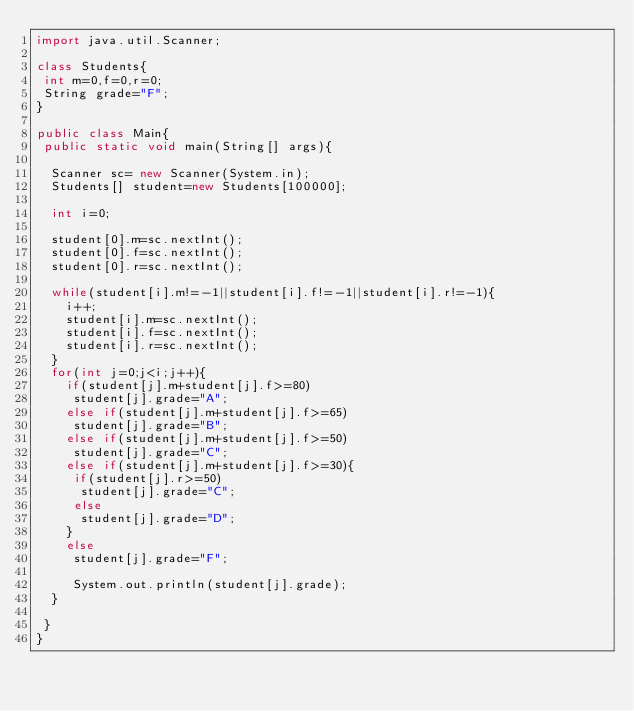Convert code to text. <code><loc_0><loc_0><loc_500><loc_500><_Java_>import java.util.Scanner;

class Students{
 int m=0,f=0,r=0;
 String grade="F";
}

public class Main{
 public static void main(String[] args){
  
  Scanner sc= new Scanner(System.in);
  Students[] student=new Students[100000];
   
  int i=0; 

  student[0].m=sc.nextInt();
  student[0].f=sc.nextInt();
  student[0].r=sc.nextInt();

  while(student[i].m!=-1||student[i].f!=-1||student[i].r!=-1){
    i++;
    student[i].m=sc.nextInt();
    student[i].f=sc.nextInt();
    student[i].r=sc.nextInt();
  }
  for(int j=0;j<i;j++){
    if(student[j].m+student[j].f>=80)
     student[j].grade="A";
    else if(student[j].m+student[j].f>=65)
     student[j].grade="B";
    else if(student[j].m+student[j].f>=50)
     student[j].grade="C";
    else if(student[j].m+student[j].f>=30){
     if(student[j].r>=50)
      student[j].grade="C";
     else
      student[j].grade="D";
    }
    else
     student[j].grade="F";

     System.out.println(student[j].grade);
  }
     
 }
}</code> 